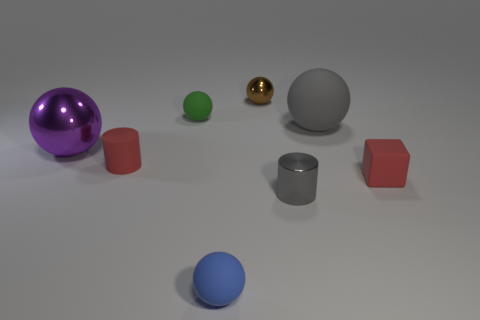Are there fewer small blue matte objects to the left of the large metal object than small brown metal balls?
Your answer should be compact. Yes. Are there any small metal cylinders right of the brown metallic ball?
Your answer should be very brief. Yes. Are there any big purple metallic things of the same shape as the small blue rubber thing?
Keep it short and to the point. Yes. There is a green rubber thing that is the same size as the brown thing; what is its shape?
Your answer should be compact. Sphere. How many objects are things on the right side of the purple metal sphere or small metallic spheres?
Provide a succinct answer. 7. Is the color of the matte cylinder the same as the matte block?
Provide a succinct answer. Yes. How big is the rubber sphere right of the blue sphere?
Your answer should be very brief. Large. Are there any purple metallic things that have the same size as the gray sphere?
Provide a short and direct response. Yes. Is the size of the blue ball left of the brown metallic sphere the same as the green matte thing?
Make the answer very short. Yes. The gray rubber sphere has what size?
Offer a very short reply. Large. 